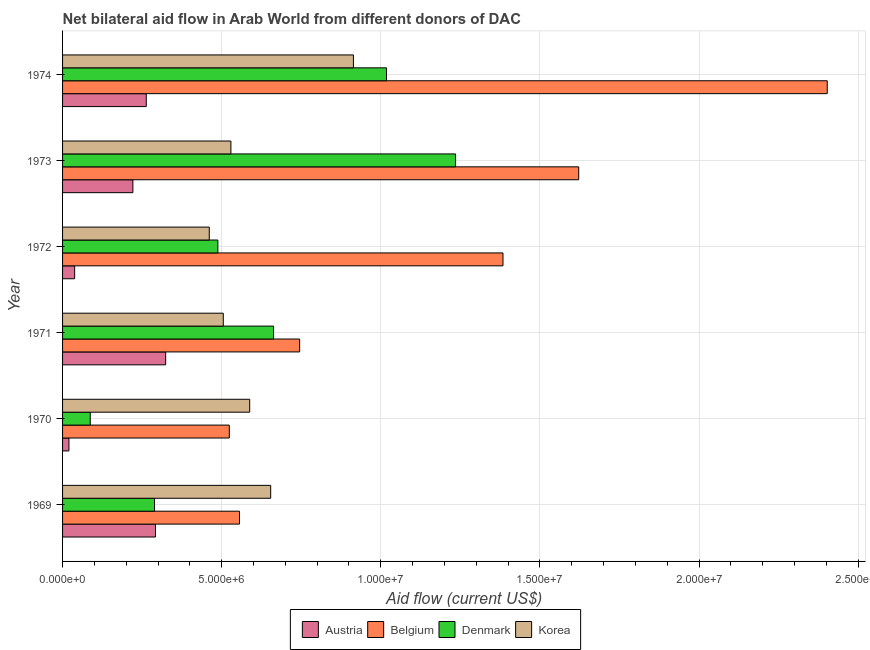Are the number of bars on each tick of the Y-axis equal?
Your answer should be compact. Yes. How many bars are there on the 1st tick from the top?
Make the answer very short. 4. What is the amount of aid given by belgium in 1974?
Offer a very short reply. 2.40e+07. Across all years, what is the maximum amount of aid given by denmark?
Ensure brevity in your answer.  1.24e+07. Across all years, what is the minimum amount of aid given by denmark?
Your answer should be very brief. 8.70e+05. In which year was the amount of aid given by korea maximum?
Ensure brevity in your answer.  1974. In which year was the amount of aid given by austria minimum?
Ensure brevity in your answer.  1970. What is the total amount of aid given by korea in the graph?
Offer a very short reply. 3.65e+07. What is the difference between the amount of aid given by denmark in 1970 and that in 1971?
Offer a terse response. -5.76e+06. What is the difference between the amount of aid given by belgium in 1974 and the amount of aid given by austria in 1973?
Offer a terse response. 2.18e+07. What is the average amount of aid given by korea per year?
Make the answer very short. 6.08e+06. In the year 1973, what is the difference between the amount of aid given by austria and amount of aid given by denmark?
Keep it short and to the point. -1.01e+07. What is the ratio of the amount of aid given by belgium in 1970 to that in 1974?
Offer a terse response. 0.22. Is the amount of aid given by austria in 1971 less than that in 1974?
Provide a succinct answer. No. What is the difference between the highest and the second highest amount of aid given by belgium?
Make the answer very short. 7.81e+06. What is the difference between the highest and the lowest amount of aid given by austria?
Provide a short and direct response. 3.04e+06. In how many years, is the amount of aid given by korea greater than the average amount of aid given by korea taken over all years?
Your answer should be compact. 2. Is the sum of the amount of aid given by belgium in 1969 and 1974 greater than the maximum amount of aid given by austria across all years?
Offer a very short reply. Yes. What does the 4th bar from the top in 1973 represents?
Your answer should be very brief. Austria. What does the 4th bar from the bottom in 1974 represents?
Offer a terse response. Korea. Are all the bars in the graph horizontal?
Offer a terse response. Yes. What is the difference between two consecutive major ticks on the X-axis?
Provide a short and direct response. 5.00e+06. Does the graph contain grids?
Provide a succinct answer. Yes. How are the legend labels stacked?
Provide a succinct answer. Horizontal. What is the title of the graph?
Make the answer very short. Net bilateral aid flow in Arab World from different donors of DAC. Does "Ease of arranging shipments" appear as one of the legend labels in the graph?
Provide a succinct answer. No. What is the label or title of the X-axis?
Keep it short and to the point. Aid flow (current US$). What is the label or title of the Y-axis?
Keep it short and to the point. Year. What is the Aid flow (current US$) of Austria in 1969?
Offer a terse response. 2.92e+06. What is the Aid flow (current US$) in Belgium in 1969?
Provide a short and direct response. 5.56e+06. What is the Aid flow (current US$) in Denmark in 1969?
Your answer should be very brief. 2.89e+06. What is the Aid flow (current US$) in Korea in 1969?
Provide a succinct answer. 6.54e+06. What is the Aid flow (current US$) in Belgium in 1970?
Make the answer very short. 5.24e+06. What is the Aid flow (current US$) in Denmark in 1970?
Make the answer very short. 8.70e+05. What is the Aid flow (current US$) in Korea in 1970?
Provide a short and direct response. 5.88e+06. What is the Aid flow (current US$) of Austria in 1971?
Your answer should be very brief. 3.24e+06. What is the Aid flow (current US$) in Belgium in 1971?
Offer a terse response. 7.45e+06. What is the Aid flow (current US$) of Denmark in 1971?
Offer a very short reply. 6.63e+06. What is the Aid flow (current US$) in Korea in 1971?
Your answer should be compact. 5.05e+06. What is the Aid flow (current US$) of Belgium in 1972?
Provide a short and direct response. 1.38e+07. What is the Aid flow (current US$) of Denmark in 1972?
Give a very brief answer. 4.88e+06. What is the Aid flow (current US$) in Korea in 1972?
Provide a short and direct response. 4.61e+06. What is the Aid flow (current US$) in Austria in 1973?
Keep it short and to the point. 2.21e+06. What is the Aid flow (current US$) of Belgium in 1973?
Your answer should be very brief. 1.62e+07. What is the Aid flow (current US$) in Denmark in 1973?
Your answer should be very brief. 1.24e+07. What is the Aid flow (current US$) of Korea in 1973?
Give a very brief answer. 5.29e+06. What is the Aid flow (current US$) in Austria in 1974?
Offer a terse response. 2.63e+06. What is the Aid flow (current US$) of Belgium in 1974?
Provide a succinct answer. 2.40e+07. What is the Aid flow (current US$) in Denmark in 1974?
Offer a terse response. 1.02e+07. What is the Aid flow (current US$) of Korea in 1974?
Ensure brevity in your answer.  9.14e+06. Across all years, what is the maximum Aid flow (current US$) of Austria?
Your answer should be compact. 3.24e+06. Across all years, what is the maximum Aid flow (current US$) of Belgium?
Provide a succinct answer. 2.40e+07. Across all years, what is the maximum Aid flow (current US$) in Denmark?
Offer a very short reply. 1.24e+07. Across all years, what is the maximum Aid flow (current US$) in Korea?
Offer a very short reply. 9.14e+06. Across all years, what is the minimum Aid flow (current US$) in Belgium?
Provide a short and direct response. 5.24e+06. Across all years, what is the minimum Aid flow (current US$) in Denmark?
Provide a succinct answer. 8.70e+05. Across all years, what is the minimum Aid flow (current US$) of Korea?
Make the answer very short. 4.61e+06. What is the total Aid flow (current US$) in Austria in the graph?
Keep it short and to the point. 1.16e+07. What is the total Aid flow (current US$) in Belgium in the graph?
Offer a very short reply. 7.23e+07. What is the total Aid flow (current US$) in Denmark in the graph?
Your answer should be compact. 3.78e+07. What is the total Aid flow (current US$) in Korea in the graph?
Offer a terse response. 3.65e+07. What is the difference between the Aid flow (current US$) in Austria in 1969 and that in 1970?
Your response must be concise. 2.72e+06. What is the difference between the Aid flow (current US$) of Belgium in 1969 and that in 1970?
Provide a succinct answer. 3.20e+05. What is the difference between the Aid flow (current US$) in Denmark in 1969 and that in 1970?
Your answer should be very brief. 2.02e+06. What is the difference between the Aid flow (current US$) in Korea in 1969 and that in 1970?
Offer a terse response. 6.60e+05. What is the difference between the Aid flow (current US$) in Austria in 1969 and that in 1971?
Keep it short and to the point. -3.20e+05. What is the difference between the Aid flow (current US$) in Belgium in 1969 and that in 1971?
Ensure brevity in your answer.  -1.89e+06. What is the difference between the Aid flow (current US$) of Denmark in 1969 and that in 1971?
Your response must be concise. -3.74e+06. What is the difference between the Aid flow (current US$) in Korea in 1969 and that in 1971?
Your answer should be compact. 1.49e+06. What is the difference between the Aid flow (current US$) of Austria in 1969 and that in 1972?
Give a very brief answer. 2.54e+06. What is the difference between the Aid flow (current US$) of Belgium in 1969 and that in 1972?
Ensure brevity in your answer.  -8.28e+06. What is the difference between the Aid flow (current US$) in Denmark in 1969 and that in 1972?
Provide a succinct answer. -1.99e+06. What is the difference between the Aid flow (current US$) in Korea in 1969 and that in 1972?
Your answer should be very brief. 1.93e+06. What is the difference between the Aid flow (current US$) of Austria in 1969 and that in 1973?
Your answer should be very brief. 7.10e+05. What is the difference between the Aid flow (current US$) of Belgium in 1969 and that in 1973?
Provide a short and direct response. -1.07e+07. What is the difference between the Aid flow (current US$) of Denmark in 1969 and that in 1973?
Your answer should be compact. -9.46e+06. What is the difference between the Aid flow (current US$) of Korea in 1969 and that in 1973?
Provide a short and direct response. 1.25e+06. What is the difference between the Aid flow (current US$) in Austria in 1969 and that in 1974?
Keep it short and to the point. 2.90e+05. What is the difference between the Aid flow (current US$) in Belgium in 1969 and that in 1974?
Offer a very short reply. -1.85e+07. What is the difference between the Aid flow (current US$) of Denmark in 1969 and that in 1974?
Keep it short and to the point. -7.29e+06. What is the difference between the Aid flow (current US$) in Korea in 1969 and that in 1974?
Offer a very short reply. -2.60e+06. What is the difference between the Aid flow (current US$) of Austria in 1970 and that in 1971?
Offer a terse response. -3.04e+06. What is the difference between the Aid flow (current US$) of Belgium in 1970 and that in 1971?
Give a very brief answer. -2.21e+06. What is the difference between the Aid flow (current US$) in Denmark in 1970 and that in 1971?
Offer a terse response. -5.76e+06. What is the difference between the Aid flow (current US$) in Korea in 1970 and that in 1971?
Ensure brevity in your answer.  8.30e+05. What is the difference between the Aid flow (current US$) in Belgium in 1970 and that in 1972?
Keep it short and to the point. -8.60e+06. What is the difference between the Aid flow (current US$) of Denmark in 1970 and that in 1972?
Provide a short and direct response. -4.01e+06. What is the difference between the Aid flow (current US$) of Korea in 1970 and that in 1972?
Ensure brevity in your answer.  1.27e+06. What is the difference between the Aid flow (current US$) of Austria in 1970 and that in 1973?
Ensure brevity in your answer.  -2.01e+06. What is the difference between the Aid flow (current US$) of Belgium in 1970 and that in 1973?
Keep it short and to the point. -1.10e+07. What is the difference between the Aid flow (current US$) of Denmark in 1970 and that in 1973?
Ensure brevity in your answer.  -1.15e+07. What is the difference between the Aid flow (current US$) of Korea in 1970 and that in 1973?
Give a very brief answer. 5.90e+05. What is the difference between the Aid flow (current US$) of Austria in 1970 and that in 1974?
Keep it short and to the point. -2.43e+06. What is the difference between the Aid flow (current US$) of Belgium in 1970 and that in 1974?
Provide a short and direct response. -1.88e+07. What is the difference between the Aid flow (current US$) in Denmark in 1970 and that in 1974?
Provide a short and direct response. -9.31e+06. What is the difference between the Aid flow (current US$) in Korea in 1970 and that in 1974?
Provide a short and direct response. -3.26e+06. What is the difference between the Aid flow (current US$) of Austria in 1971 and that in 1972?
Ensure brevity in your answer.  2.86e+06. What is the difference between the Aid flow (current US$) in Belgium in 1971 and that in 1972?
Provide a short and direct response. -6.39e+06. What is the difference between the Aid flow (current US$) in Denmark in 1971 and that in 1972?
Make the answer very short. 1.75e+06. What is the difference between the Aid flow (current US$) of Austria in 1971 and that in 1973?
Your answer should be compact. 1.03e+06. What is the difference between the Aid flow (current US$) in Belgium in 1971 and that in 1973?
Keep it short and to the point. -8.77e+06. What is the difference between the Aid flow (current US$) in Denmark in 1971 and that in 1973?
Ensure brevity in your answer.  -5.72e+06. What is the difference between the Aid flow (current US$) of Korea in 1971 and that in 1973?
Provide a succinct answer. -2.40e+05. What is the difference between the Aid flow (current US$) of Austria in 1971 and that in 1974?
Offer a very short reply. 6.10e+05. What is the difference between the Aid flow (current US$) in Belgium in 1971 and that in 1974?
Offer a terse response. -1.66e+07. What is the difference between the Aid flow (current US$) in Denmark in 1971 and that in 1974?
Provide a short and direct response. -3.55e+06. What is the difference between the Aid flow (current US$) of Korea in 1971 and that in 1974?
Ensure brevity in your answer.  -4.09e+06. What is the difference between the Aid flow (current US$) in Austria in 1972 and that in 1973?
Offer a very short reply. -1.83e+06. What is the difference between the Aid flow (current US$) in Belgium in 1972 and that in 1973?
Provide a succinct answer. -2.38e+06. What is the difference between the Aid flow (current US$) in Denmark in 1972 and that in 1973?
Your response must be concise. -7.47e+06. What is the difference between the Aid flow (current US$) in Korea in 1972 and that in 1973?
Offer a very short reply. -6.80e+05. What is the difference between the Aid flow (current US$) of Austria in 1972 and that in 1974?
Offer a terse response. -2.25e+06. What is the difference between the Aid flow (current US$) in Belgium in 1972 and that in 1974?
Offer a very short reply. -1.02e+07. What is the difference between the Aid flow (current US$) of Denmark in 1972 and that in 1974?
Provide a succinct answer. -5.30e+06. What is the difference between the Aid flow (current US$) in Korea in 1972 and that in 1974?
Your answer should be compact. -4.53e+06. What is the difference between the Aid flow (current US$) of Austria in 1973 and that in 1974?
Your response must be concise. -4.20e+05. What is the difference between the Aid flow (current US$) of Belgium in 1973 and that in 1974?
Make the answer very short. -7.81e+06. What is the difference between the Aid flow (current US$) in Denmark in 1973 and that in 1974?
Provide a short and direct response. 2.17e+06. What is the difference between the Aid flow (current US$) in Korea in 1973 and that in 1974?
Provide a succinct answer. -3.85e+06. What is the difference between the Aid flow (current US$) in Austria in 1969 and the Aid flow (current US$) in Belgium in 1970?
Offer a terse response. -2.32e+06. What is the difference between the Aid flow (current US$) of Austria in 1969 and the Aid flow (current US$) of Denmark in 1970?
Offer a terse response. 2.05e+06. What is the difference between the Aid flow (current US$) of Austria in 1969 and the Aid flow (current US$) of Korea in 1970?
Make the answer very short. -2.96e+06. What is the difference between the Aid flow (current US$) in Belgium in 1969 and the Aid flow (current US$) in Denmark in 1970?
Your answer should be compact. 4.69e+06. What is the difference between the Aid flow (current US$) of Belgium in 1969 and the Aid flow (current US$) of Korea in 1970?
Ensure brevity in your answer.  -3.20e+05. What is the difference between the Aid flow (current US$) of Denmark in 1969 and the Aid flow (current US$) of Korea in 1970?
Your response must be concise. -2.99e+06. What is the difference between the Aid flow (current US$) of Austria in 1969 and the Aid flow (current US$) of Belgium in 1971?
Provide a short and direct response. -4.53e+06. What is the difference between the Aid flow (current US$) in Austria in 1969 and the Aid flow (current US$) in Denmark in 1971?
Your answer should be compact. -3.71e+06. What is the difference between the Aid flow (current US$) in Austria in 1969 and the Aid flow (current US$) in Korea in 1971?
Provide a succinct answer. -2.13e+06. What is the difference between the Aid flow (current US$) of Belgium in 1969 and the Aid flow (current US$) of Denmark in 1971?
Keep it short and to the point. -1.07e+06. What is the difference between the Aid flow (current US$) of Belgium in 1969 and the Aid flow (current US$) of Korea in 1971?
Your answer should be compact. 5.10e+05. What is the difference between the Aid flow (current US$) of Denmark in 1969 and the Aid flow (current US$) of Korea in 1971?
Your answer should be compact. -2.16e+06. What is the difference between the Aid flow (current US$) in Austria in 1969 and the Aid flow (current US$) in Belgium in 1972?
Give a very brief answer. -1.09e+07. What is the difference between the Aid flow (current US$) in Austria in 1969 and the Aid flow (current US$) in Denmark in 1972?
Offer a very short reply. -1.96e+06. What is the difference between the Aid flow (current US$) in Austria in 1969 and the Aid flow (current US$) in Korea in 1972?
Provide a short and direct response. -1.69e+06. What is the difference between the Aid flow (current US$) of Belgium in 1969 and the Aid flow (current US$) of Denmark in 1972?
Provide a succinct answer. 6.80e+05. What is the difference between the Aid flow (current US$) in Belgium in 1969 and the Aid flow (current US$) in Korea in 1972?
Offer a terse response. 9.50e+05. What is the difference between the Aid flow (current US$) in Denmark in 1969 and the Aid flow (current US$) in Korea in 1972?
Offer a very short reply. -1.72e+06. What is the difference between the Aid flow (current US$) in Austria in 1969 and the Aid flow (current US$) in Belgium in 1973?
Make the answer very short. -1.33e+07. What is the difference between the Aid flow (current US$) in Austria in 1969 and the Aid flow (current US$) in Denmark in 1973?
Your answer should be compact. -9.43e+06. What is the difference between the Aid flow (current US$) in Austria in 1969 and the Aid flow (current US$) in Korea in 1973?
Your answer should be compact. -2.37e+06. What is the difference between the Aid flow (current US$) in Belgium in 1969 and the Aid flow (current US$) in Denmark in 1973?
Provide a succinct answer. -6.79e+06. What is the difference between the Aid flow (current US$) in Denmark in 1969 and the Aid flow (current US$) in Korea in 1973?
Give a very brief answer. -2.40e+06. What is the difference between the Aid flow (current US$) of Austria in 1969 and the Aid flow (current US$) of Belgium in 1974?
Provide a succinct answer. -2.11e+07. What is the difference between the Aid flow (current US$) of Austria in 1969 and the Aid flow (current US$) of Denmark in 1974?
Make the answer very short. -7.26e+06. What is the difference between the Aid flow (current US$) in Austria in 1969 and the Aid flow (current US$) in Korea in 1974?
Make the answer very short. -6.22e+06. What is the difference between the Aid flow (current US$) of Belgium in 1969 and the Aid flow (current US$) of Denmark in 1974?
Your response must be concise. -4.62e+06. What is the difference between the Aid flow (current US$) of Belgium in 1969 and the Aid flow (current US$) of Korea in 1974?
Make the answer very short. -3.58e+06. What is the difference between the Aid flow (current US$) in Denmark in 1969 and the Aid flow (current US$) in Korea in 1974?
Ensure brevity in your answer.  -6.25e+06. What is the difference between the Aid flow (current US$) of Austria in 1970 and the Aid flow (current US$) of Belgium in 1971?
Keep it short and to the point. -7.25e+06. What is the difference between the Aid flow (current US$) of Austria in 1970 and the Aid flow (current US$) of Denmark in 1971?
Offer a terse response. -6.43e+06. What is the difference between the Aid flow (current US$) in Austria in 1970 and the Aid flow (current US$) in Korea in 1971?
Your answer should be compact. -4.85e+06. What is the difference between the Aid flow (current US$) in Belgium in 1970 and the Aid flow (current US$) in Denmark in 1971?
Provide a short and direct response. -1.39e+06. What is the difference between the Aid flow (current US$) of Denmark in 1970 and the Aid flow (current US$) of Korea in 1971?
Your answer should be very brief. -4.18e+06. What is the difference between the Aid flow (current US$) of Austria in 1970 and the Aid flow (current US$) of Belgium in 1972?
Your answer should be very brief. -1.36e+07. What is the difference between the Aid flow (current US$) of Austria in 1970 and the Aid flow (current US$) of Denmark in 1972?
Give a very brief answer. -4.68e+06. What is the difference between the Aid flow (current US$) in Austria in 1970 and the Aid flow (current US$) in Korea in 1972?
Keep it short and to the point. -4.41e+06. What is the difference between the Aid flow (current US$) in Belgium in 1970 and the Aid flow (current US$) in Korea in 1972?
Offer a terse response. 6.30e+05. What is the difference between the Aid flow (current US$) of Denmark in 1970 and the Aid flow (current US$) of Korea in 1972?
Your answer should be very brief. -3.74e+06. What is the difference between the Aid flow (current US$) in Austria in 1970 and the Aid flow (current US$) in Belgium in 1973?
Your answer should be compact. -1.60e+07. What is the difference between the Aid flow (current US$) of Austria in 1970 and the Aid flow (current US$) of Denmark in 1973?
Provide a succinct answer. -1.22e+07. What is the difference between the Aid flow (current US$) of Austria in 1970 and the Aid flow (current US$) of Korea in 1973?
Make the answer very short. -5.09e+06. What is the difference between the Aid flow (current US$) in Belgium in 1970 and the Aid flow (current US$) in Denmark in 1973?
Ensure brevity in your answer.  -7.11e+06. What is the difference between the Aid flow (current US$) in Belgium in 1970 and the Aid flow (current US$) in Korea in 1973?
Ensure brevity in your answer.  -5.00e+04. What is the difference between the Aid flow (current US$) in Denmark in 1970 and the Aid flow (current US$) in Korea in 1973?
Your response must be concise. -4.42e+06. What is the difference between the Aid flow (current US$) of Austria in 1970 and the Aid flow (current US$) of Belgium in 1974?
Give a very brief answer. -2.38e+07. What is the difference between the Aid flow (current US$) in Austria in 1970 and the Aid flow (current US$) in Denmark in 1974?
Make the answer very short. -9.98e+06. What is the difference between the Aid flow (current US$) in Austria in 1970 and the Aid flow (current US$) in Korea in 1974?
Offer a terse response. -8.94e+06. What is the difference between the Aid flow (current US$) of Belgium in 1970 and the Aid flow (current US$) of Denmark in 1974?
Offer a very short reply. -4.94e+06. What is the difference between the Aid flow (current US$) in Belgium in 1970 and the Aid flow (current US$) in Korea in 1974?
Your answer should be compact. -3.90e+06. What is the difference between the Aid flow (current US$) of Denmark in 1970 and the Aid flow (current US$) of Korea in 1974?
Provide a succinct answer. -8.27e+06. What is the difference between the Aid flow (current US$) in Austria in 1971 and the Aid flow (current US$) in Belgium in 1972?
Your response must be concise. -1.06e+07. What is the difference between the Aid flow (current US$) in Austria in 1971 and the Aid flow (current US$) in Denmark in 1972?
Your response must be concise. -1.64e+06. What is the difference between the Aid flow (current US$) of Austria in 1971 and the Aid flow (current US$) of Korea in 1972?
Keep it short and to the point. -1.37e+06. What is the difference between the Aid flow (current US$) in Belgium in 1971 and the Aid flow (current US$) in Denmark in 1972?
Your answer should be very brief. 2.57e+06. What is the difference between the Aid flow (current US$) in Belgium in 1971 and the Aid flow (current US$) in Korea in 1972?
Provide a short and direct response. 2.84e+06. What is the difference between the Aid flow (current US$) of Denmark in 1971 and the Aid flow (current US$) of Korea in 1972?
Give a very brief answer. 2.02e+06. What is the difference between the Aid flow (current US$) in Austria in 1971 and the Aid flow (current US$) in Belgium in 1973?
Make the answer very short. -1.30e+07. What is the difference between the Aid flow (current US$) in Austria in 1971 and the Aid flow (current US$) in Denmark in 1973?
Make the answer very short. -9.11e+06. What is the difference between the Aid flow (current US$) of Austria in 1971 and the Aid flow (current US$) of Korea in 1973?
Give a very brief answer. -2.05e+06. What is the difference between the Aid flow (current US$) of Belgium in 1971 and the Aid flow (current US$) of Denmark in 1973?
Your answer should be very brief. -4.90e+06. What is the difference between the Aid flow (current US$) of Belgium in 1971 and the Aid flow (current US$) of Korea in 1973?
Your answer should be compact. 2.16e+06. What is the difference between the Aid flow (current US$) in Denmark in 1971 and the Aid flow (current US$) in Korea in 1973?
Make the answer very short. 1.34e+06. What is the difference between the Aid flow (current US$) in Austria in 1971 and the Aid flow (current US$) in Belgium in 1974?
Ensure brevity in your answer.  -2.08e+07. What is the difference between the Aid flow (current US$) in Austria in 1971 and the Aid flow (current US$) in Denmark in 1974?
Your answer should be compact. -6.94e+06. What is the difference between the Aid flow (current US$) of Austria in 1971 and the Aid flow (current US$) of Korea in 1974?
Offer a terse response. -5.90e+06. What is the difference between the Aid flow (current US$) of Belgium in 1971 and the Aid flow (current US$) of Denmark in 1974?
Your answer should be compact. -2.73e+06. What is the difference between the Aid flow (current US$) in Belgium in 1971 and the Aid flow (current US$) in Korea in 1974?
Keep it short and to the point. -1.69e+06. What is the difference between the Aid flow (current US$) in Denmark in 1971 and the Aid flow (current US$) in Korea in 1974?
Offer a terse response. -2.51e+06. What is the difference between the Aid flow (current US$) of Austria in 1972 and the Aid flow (current US$) of Belgium in 1973?
Ensure brevity in your answer.  -1.58e+07. What is the difference between the Aid flow (current US$) of Austria in 1972 and the Aid flow (current US$) of Denmark in 1973?
Ensure brevity in your answer.  -1.20e+07. What is the difference between the Aid flow (current US$) of Austria in 1972 and the Aid flow (current US$) of Korea in 1973?
Offer a very short reply. -4.91e+06. What is the difference between the Aid flow (current US$) of Belgium in 1972 and the Aid flow (current US$) of Denmark in 1973?
Make the answer very short. 1.49e+06. What is the difference between the Aid flow (current US$) of Belgium in 1972 and the Aid flow (current US$) of Korea in 1973?
Provide a short and direct response. 8.55e+06. What is the difference between the Aid flow (current US$) of Denmark in 1972 and the Aid flow (current US$) of Korea in 1973?
Offer a terse response. -4.10e+05. What is the difference between the Aid flow (current US$) of Austria in 1972 and the Aid flow (current US$) of Belgium in 1974?
Provide a short and direct response. -2.36e+07. What is the difference between the Aid flow (current US$) of Austria in 1972 and the Aid flow (current US$) of Denmark in 1974?
Provide a short and direct response. -9.80e+06. What is the difference between the Aid flow (current US$) of Austria in 1972 and the Aid flow (current US$) of Korea in 1974?
Your response must be concise. -8.76e+06. What is the difference between the Aid flow (current US$) of Belgium in 1972 and the Aid flow (current US$) of Denmark in 1974?
Offer a very short reply. 3.66e+06. What is the difference between the Aid flow (current US$) in Belgium in 1972 and the Aid flow (current US$) in Korea in 1974?
Ensure brevity in your answer.  4.70e+06. What is the difference between the Aid flow (current US$) in Denmark in 1972 and the Aid flow (current US$) in Korea in 1974?
Your response must be concise. -4.26e+06. What is the difference between the Aid flow (current US$) in Austria in 1973 and the Aid flow (current US$) in Belgium in 1974?
Ensure brevity in your answer.  -2.18e+07. What is the difference between the Aid flow (current US$) in Austria in 1973 and the Aid flow (current US$) in Denmark in 1974?
Your response must be concise. -7.97e+06. What is the difference between the Aid flow (current US$) of Austria in 1973 and the Aid flow (current US$) of Korea in 1974?
Your answer should be compact. -6.93e+06. What is the difference between the Aid flow (current US$) in Belgium in 1973 and the Aid flow (current US$) in Denmark in 1974?
Give a very brief answer. 6.04e+06. What is the difference between the Aid flow (current US$) of Belgium in 1973 and the Aid flow (current US$) of Korea in 1974?
Keep it short and to the point. 7.08e+06. What is the difference between the Aid flow (current US$) in Denmark in 1973 and the Aid flow (current US$) in Korea in 1974?
Give a very brief answer. 3.21e+06. What is the average Aid flow (current US$) in Austria per year?
Your response must be concise. 1.93e+06. What is the average Aid flow (current US$) in Belgium per year?
Your answer should be very brief. 1.21e+07. What is the average Aid flow (current US$) of Denmark per year?
Keep it short and to the point. 6.30e+06. What is the average Aid flow (current US$) of Korea per year?
Make the answer very short. 6.08e+06. In the year 1969, what is the difference between the Aid flow (current US$) of Austria and Aid flow (current US$) of Belgium?
Your answer should be compact. -2.64e+06. In the year 1969, what is the difference between the Aid flow (current US$) in Austria and Aid flow (current US$) in Denmark?
Provide a succinct answer. 3.00e+04. In the year 1969, what is the difference between the Aid flow (current US$) of Austria and Aid flow (current US$) of Korea?
Ensure brevity in your answer.  -3.62e+06. In the year 1969, what is the difference between the Aid flow (current US$) of Belgium and Aid flow (current US$) of Denmark?
Your answer should be compact. 2.67e+06. In the year 1969, what is the difference between the Aid flow (current US$) of Belgium and Aid flow (current US$) of Korea?
Your response must be concise. -9.80e+05. In the year 1969, what is the difference between the Aid flow (current US$) of Denmark and Aid flow (current US$) of Korea?
Provide a short and direct response. -3.65e+06. In the year 1970, what is the difference between the Aid flow (current US$) in Austria and Aid flow (current US$) in Belgium?
Make the answer very short. -5.04e+06. In the year 1970, what is the difference between the Aid flow (current US$) in Austria and Aid flow (current US$) in Denmark?
Keep it short and to the point. -6.70e+05. In the year 1970, what is the difference between the Aid flow (current US$) in Austria and Aid flow (current US$) in Korea?
Keep it short and to the point. -5.68e+06. In the year 1970, what is the difference between the Aid flow (current US$) in Belgium and Aid flow (current US$) in Denmark?
Keep it short and to the point. 4.37e+06. In the year 1970, what is the difference between the Aid flow (current US$) in Belgium and Aid flow (current US$) in Korea?
Provide a short and direct response. -6.40e+05. In the year 1970, what is the difference between the Aid flow (current US$) of Denmark and Aid flow (current US$) of Korea?
Keep it short and to the point. -5.01e+06. In the year 1971, what is the difference between the Aid flow (current US$) of Austria and Aid flow (current US$) of Belgium?
Offer a terse response. -4.21e+06. In the year 1971, what is the difference between the Aid flow (current US$) in Austria and Aid flow (current US$) in Denmark?
Keep it short and to the point. -3.39e+06. In the year 1971, what is the difference between the Aid flow (current US$) of Austria and Aid flow (current US$) of Korea?
Keep it short and to the point. -1.81e+06. In the year 1971, what is the difference between the Aid flow (current US$) of Belgium and Aid flow (current US$) of Denmark?
Your answer should be very brief. 8.20e+05. In the year 1971, what is the difference between the Aid flow (current US$) in Belgium and Aid flow (current US$) in Korea?
Provide a succinct answer. 2.40e+06. In the year 1971, what is the difference between the Aid flow (current US$) in Denmark and Aid flow (current US$) in Korea?
Offer a terse response. 1.58e+06. In the year 1972, what is the difference between the Aid flow (current US$) of Austria and Aid flow (current US$) of Belgium?
Keep it short and to the point. -1.35e+07. In the year 1972, what is the difference between the Aid flow (current US$) in Austria and Aid flow (current US$) in Denmark?
Ensure brevity in your answer.  -4.50e+06. In the year 1972, what is the difference between the Aid flow (current US$) in Austria and Aid flow (current US$) in Korea?
Make the answer very short. -4.23e+06. In the year 1972, what is the difference between the Aid flow (current US$) in Belgium and Aid flow (current US$) in Denmark?
Provide a short and direct response. 8.96e+06. In the year 1972, what is the difference between the Aid flow (current US$) in Belgium and Aid flow (current US$) in Korea?
Your answer should be very brief. 9.23e+06. In the year 1973, what is the difference between the Aid flow (current US$) in Austria and Aid flow (current US$) in Belgium?
Ensure brevity in your answer.  -1.40e+07. In the year 1973, what is the difference between the Aid flow (current US$) of Austria and Aid flow (current US$) of Denmark?
Give a very brief answer. -1.01e+07. In the year 1973, what is the difference between the Aid flow (current US$) of Austria and Aid flow (current US$) of Korea?
Provide a succinct answer. -3.08e+06. In the year 1973, what is the difference between the Aid flow (current US$) of Belgium and Aid flow (current US$) of Denmark?
Your answer should be compact. 3.87e+06. In the year 1973, what is the difference between the Aid flow (current US$) of Belgium and Aid flow (current US$) of Korea?
Your answer should be compact. 1.09e+07. In the year 1973, what is the difference between the Aid flow (current US$) of Denmark and Aid flow (current US$) of Korea?
Provide a succinct answer. 7.06e+06. In the year 1974, what is the difference between the Aid flow (current US$) in Austria and Aid flow (current US$) in Belgium?
Offer a very short reply. -2.14e+07. In the year 1974, what is the difference between the Aid flow (current US$) in Austria and Aid flow (current US$) in Denmark?
Ensure brevity in your answer.  -7.55e+06. In the year 1974, what is the difference between the Aid flow (current US$) of Austria and Aid flow (current US$) of Korea?
Keep it short and to the point. -6.51e+06. In the year 1974, what is the difference between the Aid flow (current US$) of Belgium and Aid flow (current US$) of Denmark?
Keep it short and to the point. 1.38e+07. In the year 1974, what is the difference between the Aid flow (current US$) in Belgium and Aid flow (current US$) in Korea?
Your answer should be very brief. 1.49e+07. In the year 1974, what is the difference between the Aid flow (current US$) of Denmark and Aid flow (current US$) of Korea?
Provide a short and direct response. 1.04e+06. What is the ratio of the Aid flow (current US$) in Belgium in 1969 to that in 1970?
Your answer should be compact. 1.06. What is the ratio of the Aid flow (current US$) in Denmark in 1969 to that in 1970?
Offer a very short reply. 3.32. What is the ratio of the Aid flow (current US$) in Korea in 1969 to that in 1970?
Offer a terse response. 1.11. What is the ratio of the Aid flow (current US$) in Austria in 1969 to that in 1971?
Ensure brevity in your answer.  0.9. What is the ratio of the Aid flow (current US$) of Belgium in 1969 to that in 1971?
Provide a short and direct response. 0.75. What is the ratio of the Aid flow (current US$) of Denmark in 1969 to that in 1971?
Offer a very short reply. 0.44. What is the ratio of the Aid flow (current US$) of Korea in 1969 to that in 1971?
Provide a succinct answer. 1.29. What is the ratio of the Aid flow (current US$) in Austria in 1969 to that in 1972?
Provide a succinct answer. 7.68. What is the ratio of the Aid flow (current US$) in Belgium in 1969 to that in 1972?
Keep it short and to the point. 0.4. What is the ratio of the Aid flow (current US$) in Denmark in 1969 to that in 1972?
Your answer should be compact. 0.59. What is the ratio of the Aid flow (current US$) in Korea in 1969 to that in 1972?
Offer a very short reply. 1.42. What is the ratio of the Aid flow (current US$) in Austria in 1969 to that in 1973?
Give a very brief answer. 1.32. What is the ratio of the Aid flow (current US$) of Belgium in 1969 to that in 1973?
Offer a very short reply. 0.34. What is the ratio of the Aid flow (current US$) in Denmark in 1969 to that in 1973?
Make the answer very short. 0.23. What is the ratio of the Aid flow (current US$) in Korea in 1969 to that in 1973?
Ensure brevity in your answer.  1.24. What is the ratio of the Aid flow (current US$) of Austria in 1969 to that in 1974?
Offer a terse response. 1.11. What is the ratio of the Aid flow (current US$) of Belgium in 1969 to that in 1974?
Offer a terse response. 0.23. What is the ratio of the Aid flow (current US$) in Denmark in 1969 to that in 1974?
Give a very brief answer. 0.28. What is the ratio of the Aid flow (current US$) of Korea in 1969 to that in 1974?
Keep it short and to the point. 0.72. What is the ratio of the Aid flow (current US$) in Austria in 1970 to that in 1971?
Provide a short and direct response. 0.06. What is the ratio of the Aid flow (current US$) in Belgium in 1970 to that in 1971?
Provide a short and direct response. 0.7. What is the ratio of the Aid flow (current US$) of Denmark in 1970 to that in 1971?
Provide a succinct answer. 0.13. What is the ratio of the Aid flow (current US$) in Korea in 1970 to that in 1971?
Ensure brevity in your answer.  1.16. What is the ratio of the Aid flow (current US$) in Austria in 1970 to that in 1972?
Give a very brief answer. 0.53. What is the ratio of the Aid flow (current US$) in Belgium in 1970 to that in 1972?
Give a very brief answer. 0.38. What is the ratio of the Aid flow (current US$) in Denmark in 1970 to that in 1972?
Offer a very short reply. 0.18. What is the ratio of the Aid flow (current US$) of Korea in 1970 to that in 1972?
Offer a terse response. 1.28. What is the ratio of the Aid flow (current US$) in Austria in 1970 to that in 1973?
Your answer should be very brief. 0.09. What is the ratio of the Aid flow (current US$) of Belgium in 1970 to that in 1973?
Provide a short and direct response. 0.32. What is the ratio of the Aid flow (current US$) of Denmark in 1970 to that in 1973?
Make the answer very short. 0.07. What is the ratio of the Aid flow (current US$) in Korea in 1970 to that in 1973?
Give a very brief answer. 1.11. What is the ratio of the Aid flow (current US$) in Austria in 1970 to that in 1974?
Ensure brevity in your answer.  0.08. What is the ratio of the Aid flow (current US$) of Belgium in 1970 to that in 1974?
Your answer should be very brief. 0.22. What is the ratio of the Aid flow (current US$) in Denmark in 1970 to that in 1974?
Keep it short and to the point. 0.09. What is the ratio of the Aid flow (current US$) in Korea in 1970 to that in 1974?
Your response must be concise. 0.64. What is the ratio of the Aid flow (current US$) in Austria in 1971 to that in 1972?
Give a very brief answer. 8.53. What is the ratio of the Aid flow (current US$) of Belgium in 1971 to that in 1972?
Provide a succinct answer. 0.54. What is the ratio of the Aid flow (current US$) of Denmark in 1971 to that in 1972?
Provide a short and direct response. 1.36. What is the ratio of the Aid flow (current US$) of Korea in 1971 to that in 1972?
Offer a very short reply. 1.1. What is the ratio of the Aid flow (current US$) of Austria in 1971 to that in 1973?
Provide a short and direct response. 1.47. What is the ratio of the Aid flow (current US$) of Belgium in 1971 to that in 1973?
Ensure brevity in your answer.  0.46. What is the ratio of the Aid flow (current US$) in Denmark in 1971 to that in 1973?
Your answer should be very brief. 0.54. What is the ratio of the Aid flow (current US$) of Korea in 1971 to that in 1973?
Provide a short and direct response. 0.95. What is the ratio of the Aid flow (current US$) of Austria in 1971 to that in 1974?
Make the answer very short. 1.23. What is the ratio of the Aid flow (current US$) of Belgium in 1971 to that in 1974?
Keep it short and to the point. 0.31. What is the ratio of the Aid flow (current US$) in Denmark in 1971 to that in 1974?
Offer a very short reply. 0.65. What is the ratio of the Aid flow (current US$) of Korea in 1971 to that in 1974?
Your answer should be very brief. 0.55. What is the ratio of the Aid flow (current US$) in Austria in 1972 to that in 1973?
Ensure brevity in your answer.  0.17. What is the ratio of the Aid flow (current US$) in Belgium in 1972 to that in 1973?
Give a very brief answer. 0.85. What is the ratio of the Aid flow (current US$) of Denmark in 1972 to that in 1973?
Keep it short and to the point. 0.4. What is the ratio of the Aid flow (current US$) in Korea in 1972 to that in 1973?
Ensure brevity in your answer.  0.87. What is the ratio of the Aid flow (current US$) of Austria in 1972 to that in 1974?
Your response must be concise. 0.14. What is the ratio of the Aid flow (current US$) in Belgium in 1972 to that in 1974?
Keep it short and to the point. 0.58. What is the ratio of the Aid flow (current US$) of Denmark in 1972 to that in 1974?
Offer a very short reply. 0.48. What is the ratio of the Aid flow (current US$) of Korea in 1972 to that in 1974?
Your response must be concise. 0.5. What is the ratio of the Aid flow (current US$) of Austria in 1973 to that in 1974?
Offer a terse response. 0.84. What is the ratio of the Aid flow (current US$) of Belgium in 1973 to that in 1974?
Ensure brevity in your answer.  0.68. What is the ratio of the Aid flow (current US$) of Denmark in 1973 to that in 1974?
Your answer should be compact. 1.21. What is the ratio of the Aid flow (current US$) of Korea in 1973 to that in 1974?
Your answer should be compact. 0.58. What is the difference between the highest and the second highest Aid flow (current US$) in Belgium?
Ensure brevity in your answer.  7.81e+06. What is the difference between the highest and the second highest Aid flow (current US$) of Denmark?
Offer a very short reply. 2.17e+06. What is the difference between the highest and the second highest Aid flow (current US$) in Korea?
Offer a terse response. 2.60e+06. What is the difference between the highest and the lowest Aid flow (current US$) of Austria?
Offer a very short reply. 3.04e+06. What is the difference between the highest and the lowest Aid flow (current US$) of Belgium?
Keep it short and to the point. 1.88e+07. What is the difference between the highest and the lowest Aid flow (current US$) in Denmark?
Make the answer very short. 1.15e+07. What is the difference between the highest and the lowest Aid flow (current US$) of Korea?
Provide a short and direct response. 4.53e+06. 